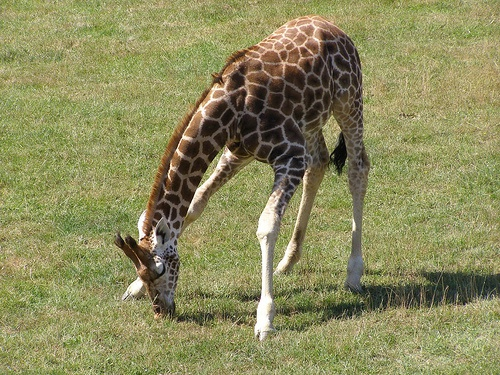Describe the objects in this image and their specific colors. I can see a giraffe in olive, black, and gray tones in this image. 